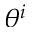Convert formula to latex. <formula><loc_0><loc_0><loc_500><loc_500>\theta ^ { i }</formula> 